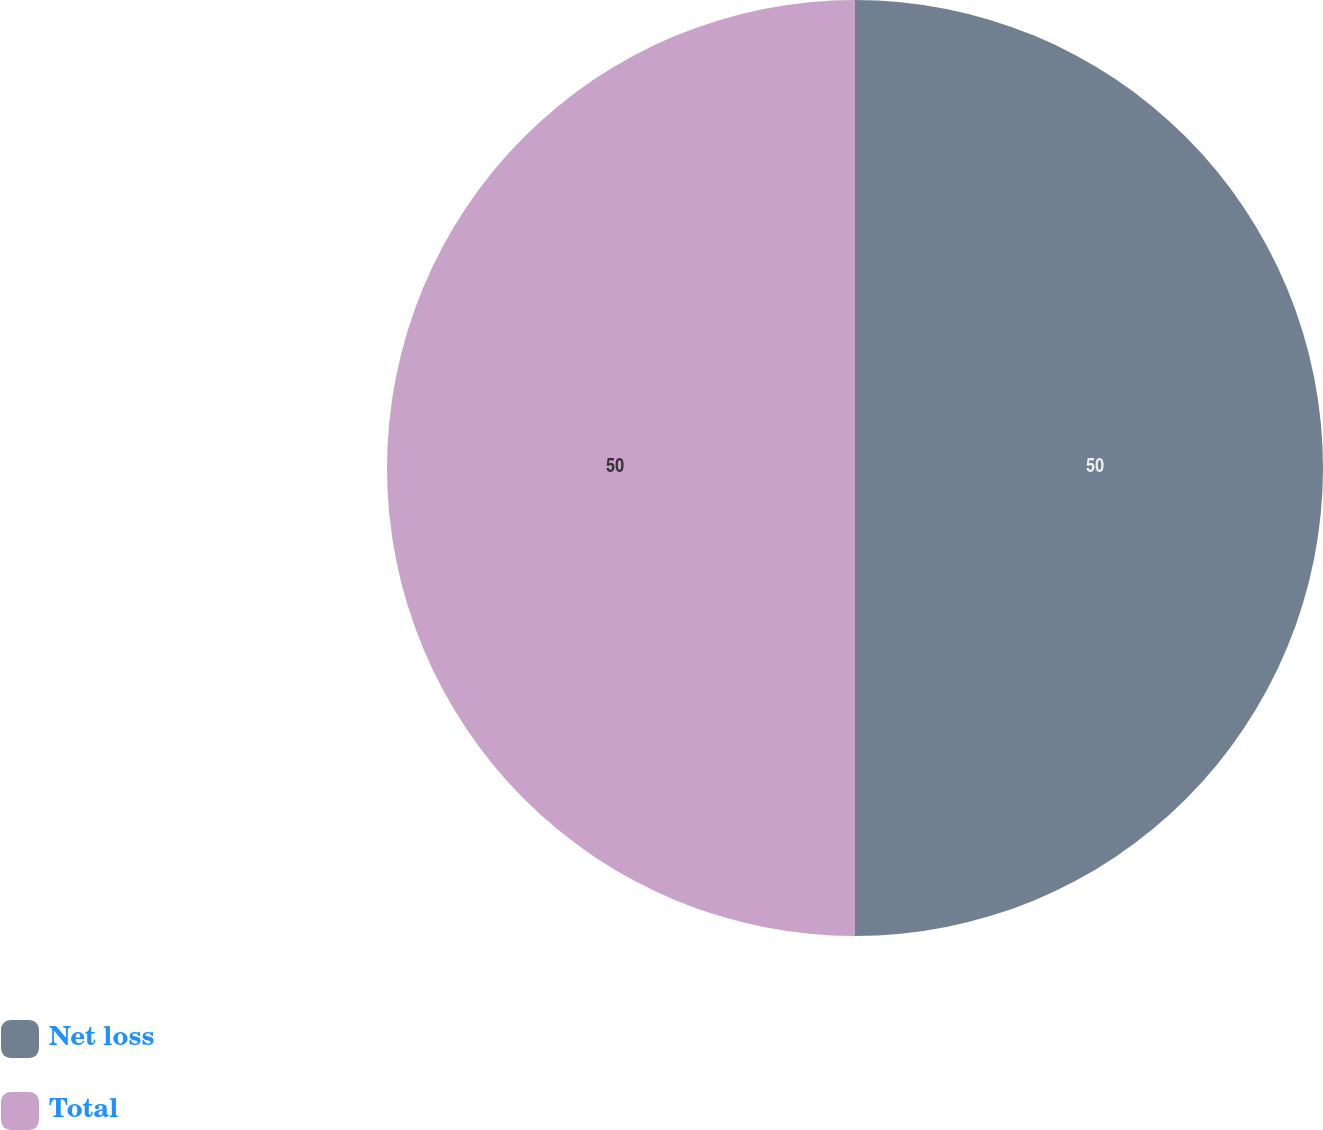Convert chart to OTSL. <chart><loc_0><loc_0><loc_500><loc_500><pie_chart><fcel>Net loss<fcel>Total<nl><fcel>50.0%<fcel>50.0%<nl></chart> 